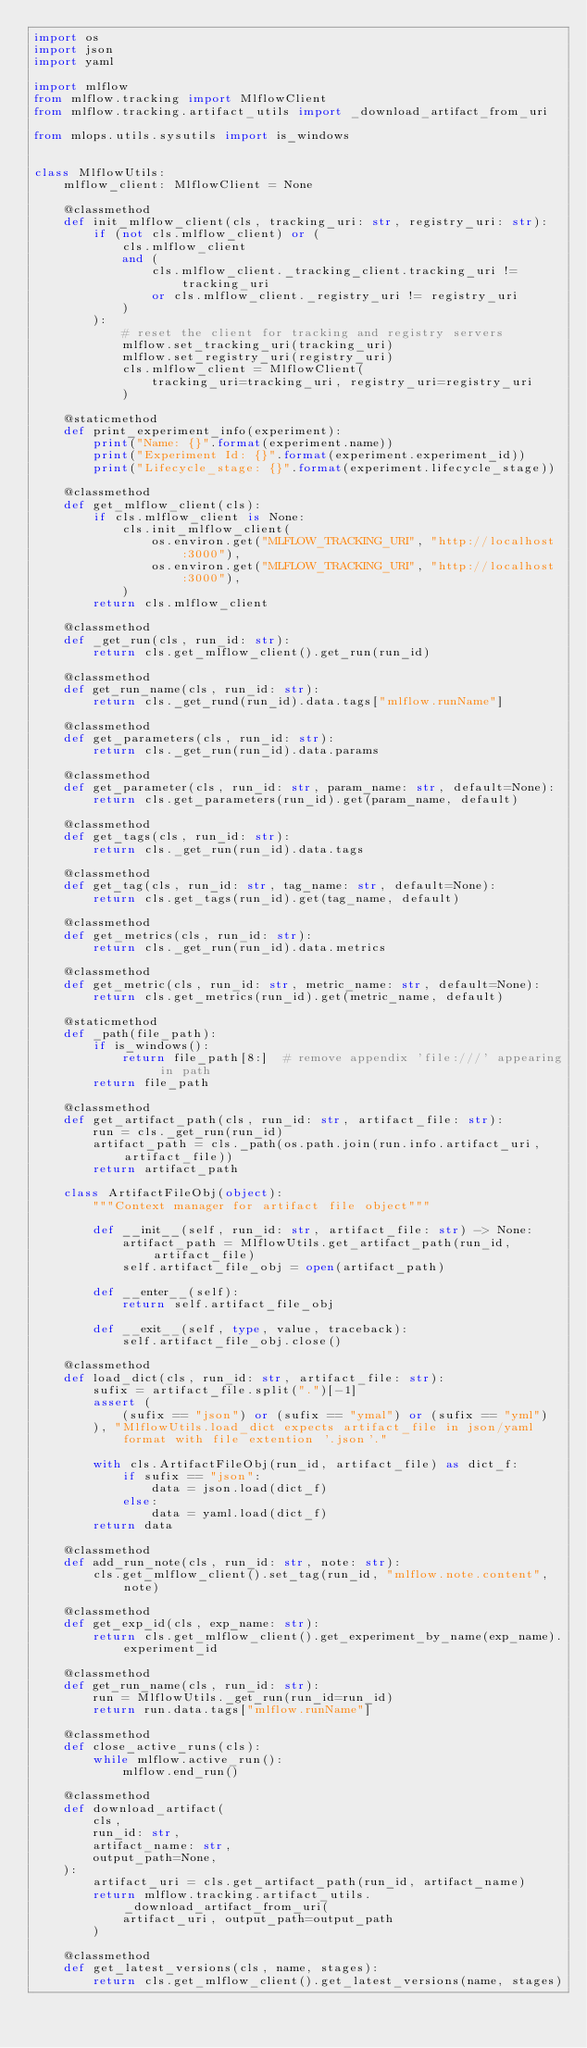<code> <loc_0><loc_0><loc_500><loc_500><_Python_>import os
import json
import yaml

import mlflow
from mlflow.tracking import MlflowClient
from mlflow.tracking.artifact_utils import _download_artifact_from_uri

from mlops.utils.sysutils import is_windows


class MlflowUtils:
    mlflow_client: MlflowClient = None

    @classmethod
    def init_mlflow_client(cls, tracking_uri: str, registry_uri: str):
        if (not cls.mlflow_client) or (
            cls.mlflow_client
            and (
                cls.mlflow_client._tracking_client.tracking_uri != tracking_uri
                or cls.mlflow_client._registry_uri != registry_uri
            )
        ):
            # reset the client for tracking and registry servers
            mlflow.set_tracking_uri(tracking_uri)
            mlflow.set_registry_uri(registry_uri)
            cls.mlflow_client = MlflowClient(
                tracking_uri=tracking_uri, registry_uri=registry_uri
            )

    @staticmethod
    def print_experiment_info(experiment):
        print("Name: {}".format(experiment.name))
        print("Experiment Id: {}".format(experiment.experiment_id))
        print("Lifecycle_stage: {}".format(experiment.lifecycle_stage))

    @classmethod
    def get_mlflow_client(cls):
        if cls.mlflow_client is None:
            cls.init_mlflow_client(
                os.environ.get("MLFLOW_TRACKING_URI", "http://localhost:3000"),
                os.environ.get("MLFLOW_TRACKING_URI", "http://localhost:3000"),
            )
        return cls.mlflow_client

    @classmethod
    def _get_run(cls, run_id: str):
        return cls.get_mlflow_client().get_run(run_id)

    @classmethod
    def get_run_name(cls, run_id: str):
        return cls._get_rund(run_id).data.tags["mlflow.runName"]

    @classmethod
    def get_parameters(cls, run_id: str):
        return cls._get_run(run_id).data.params

    @classmethod
    def get_parameter(cls, run_id: str, param_name: str, default=None):
        return cls.get_parameters(run_id).get(param_name, default)

    @classmethod
    def get_tags(cls, run_id: str):
        return cls._get_run(run_id).data.tags

    @classmethod
    def get_tag(cls, run_id: str, tag_name: str, default=None):
        return cls.get_tags(run_id).get(tag_name, default)

    @classmethod
    def get_metrics(cls, run_id: str):
        return cls._get_run(run_id).data.metrics

    @classmethod
    def get_metric(cls, run_id: str, metric_name: str, default=None):
        return cls.get_metrics(run_id).get(metric_name, default)

    @staticmethod
    def _path(file_path):
        if is_windows():
            return file_path[8:]  # remove appendix 'file:///' appearing in path
        return file_path

    @classmethod
    def get_artifact_path(cls, run_id: str, artifact_file: str):
        run = cls._get_run(run_id)
        artifact_path = cls._path(os.path.join(run.info.artifact_uri, artifact_file))
        return artifact_path

    class ArtifactFileObj(object):
        """Context manager for artifact file object"""

        def __init__(self, run_id: str, artifact_file: str) -> None:
            artifact_path = MlflowUtils.get_artifact_path(run_id, artifact_file)
            self.artifact_file_obj = open(artifact_path)

        def __enter__(self):
            return self.artifact_file_obj

        def __exit__(self, type, value, traceback):
            self.artifact_file_obj.close()

    @classmethod
    def load_dict(cls, run_id: str, artifact_file: str):
        sufix = artifact_file.split(".")[-1]
        assert (
            (sufix == "json") or (sufix == "ymal") or (sufix == "yml")
        ), "MlflowUtils.load_dict expects artifact_file in json/yaml format with file extention '.json'."

        with cls.ArtifactFileObj(run_id, artifact_file) as dict_f:
            if sufix == "json":
                data = json.load(dict_f)
            else:
                data = yaml.load(dict_f)
        return data

    @classmethod
    def add_run_note(cls, run_id: str, note: str):
        cls.get_mlflow_client().set_tag(run_id, "mlflow.note.content", note)

    @classmethod
    def get_exp_id(cls, exp_name: str):
        return cls.get_mlflow_client().get_experiment_by_name(exp_name).experiment_id

    @classmethod
    def get_run_name(cls, run_id: str):
        run = MlflowUtils._get_run(run_id=run_id)
        return run.data.tags["mlflow.runName"]

    @classmethod
    def close_active_runs(cls):
        while mlflow.active_run():
            mlflow.end_run()

    @classmethod
    def download_artifact(
        cls,
        run_id: str,
        artifact_name: str,
        output_path=None,
    ):
        artifact_uri = cls.get_artifact_path(run_id, artifact_name)
        return mlflow.tracking.artifact_utils._download_artifact_from_uri(
            artifact_uri, output_path=output_path
        )

    @classmethod
    def get_latest_versions(cls, name, stages):
        return cls.get_mlflow_client().get_latest_versions(name, stages)
</code> 